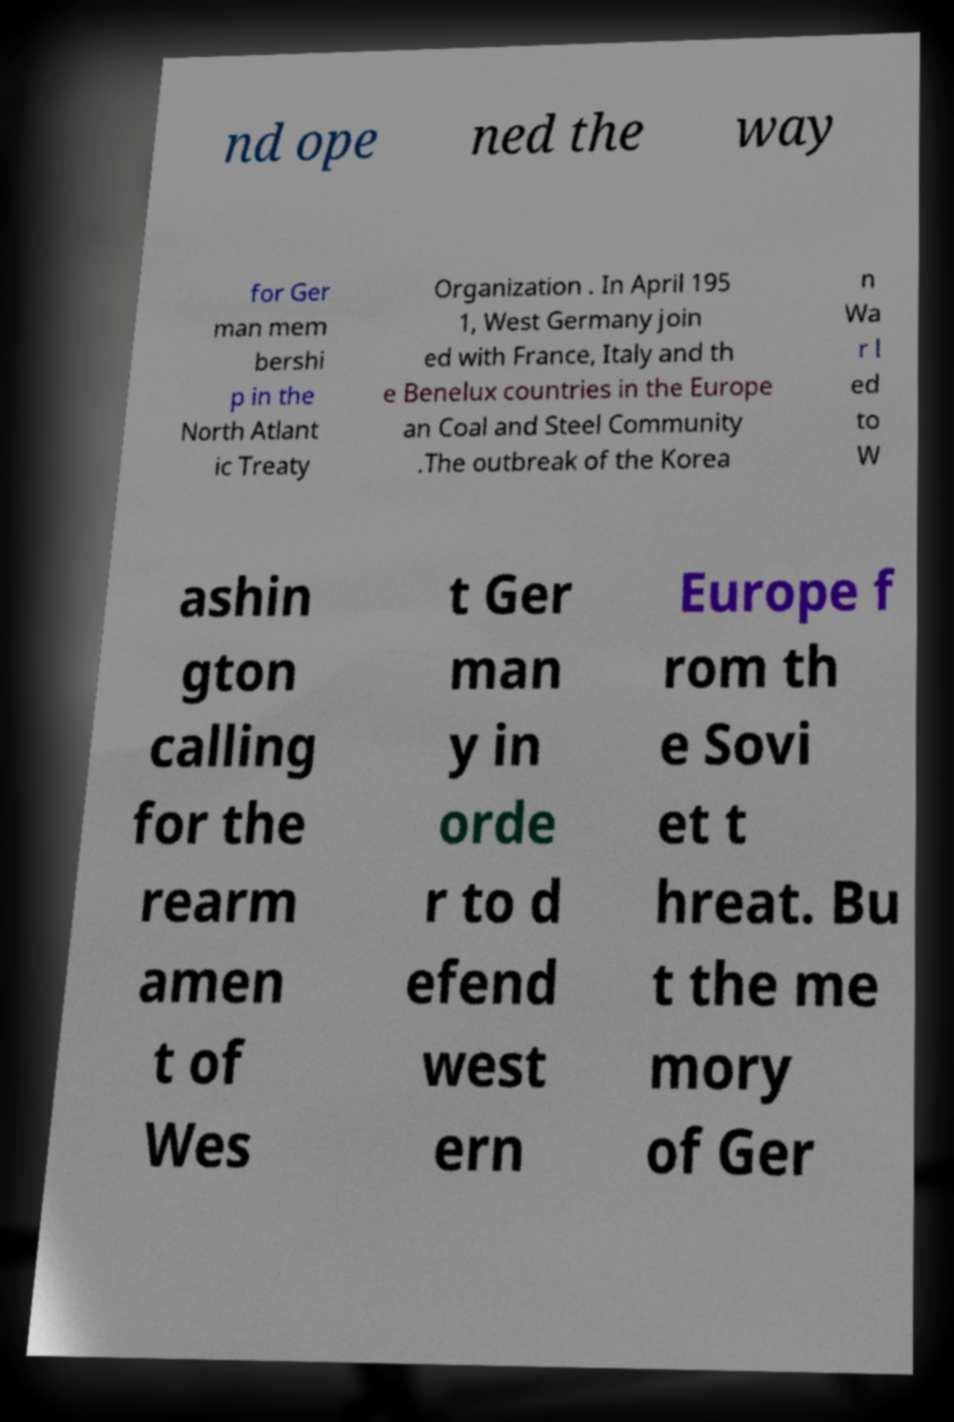I need the written content from this picture converted into text. Can you do that? nd ope ned the way for Ger man mem bershi p in the North Atlant ic Treaty Organization . In April 195 1, West Germany join ed with France, Italy and th e Benelux countries in the Europe an Coal and Steel Community .The outbreak of the Korea n Wa r l ed to W ashin gton calling for the rearm amen t of Wes t Ger man y in orde r to d efend west ern Europe f rom th e Sovi et t hreat. Bu t the me mory of Ger 